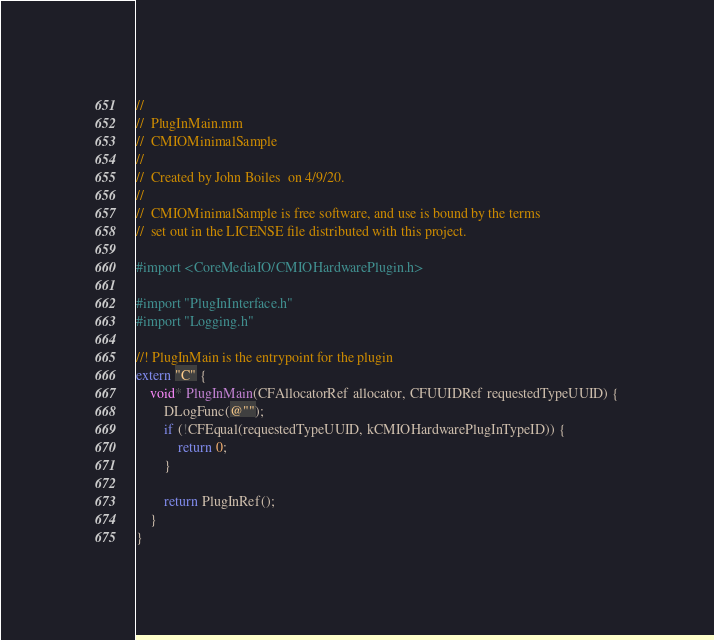<code> <loc_0><loc_0><loc_500><loc_500><_ObjectiveC_>//
//  PlugInMain.mm
//  CMIOMinimalSample
//
//  Created by John Boiles  on 4/9/20.
//
//  CMIOMinimalSample is free software, and use is bound by the terms
//  set out in the LICENSE file distributed with this project.

#import <CoreMediaIO/CMIOHardwarePlugin.h>

#import "PlugInInterface.h"
#import "Logging.h"

//! PlugInMain is the entrypoint for the plugin
extern "C" {
    void* PlugInMain(CFAllocatorRef allocator, CFUUIDRef requestedTypeUUID) {
        DLogFunc(@"");
        if (!CFEqual(requestedTypeUUID, kCMIOHardwarePlugInTypeID)) {
            return 0;
        }

        return PlugInRef();
    }
}
</code> 